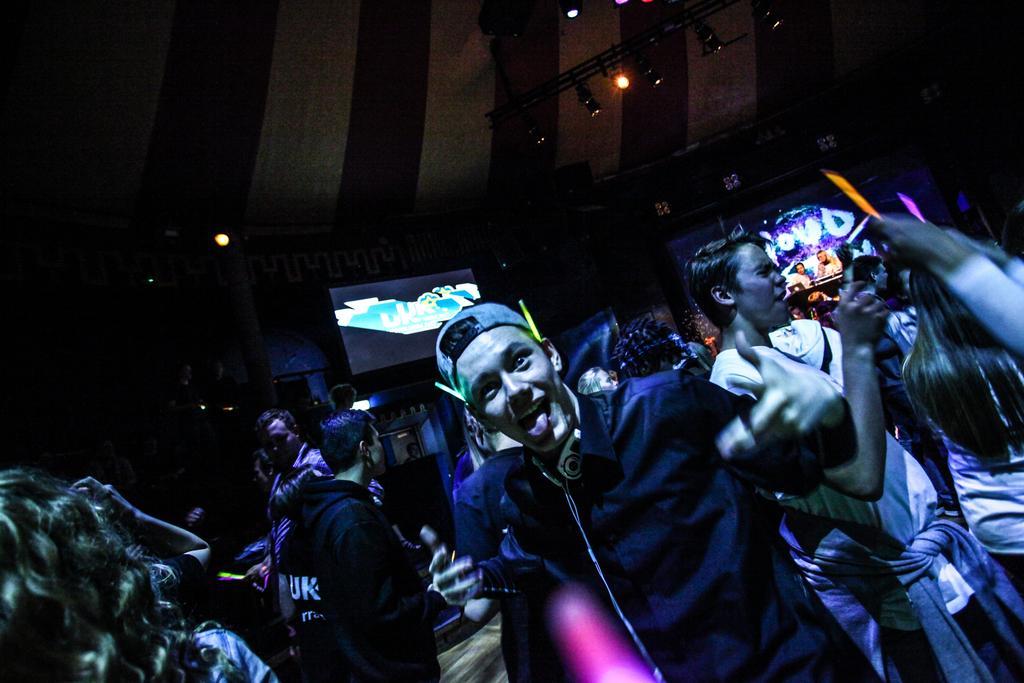Can you describe this image briefly? In this image I can see the group of people with different color dresses. I can see one person wearing the cap. In the background there are screens and lights in the top. 